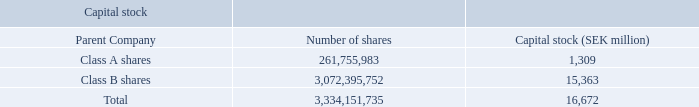Capital stock 2019
Capital stock at December 31, 2019, consisted of the following:
The capital stock of the Parent Company is divided into two classes: Class A shares (quota value SEK 5.00) and Class B shares (quota value SEK 5.00). Both classes have the same rights of participation in the net assets and earnings.Class A shares, however, are entitled to one vote per share while Class B shares are entitled to one tenth of one vote per share.
At December 31, 2019, the total number of treasury shares was 19,853,247 (37,057,039 in 2018 and 50,265,499 in 2017) Class B shares.
How are the capital stock of the parent company divided? Class a shares (quota value sek 5.00) and class b shares (quota value sek 5.00). What is the total number of treasury shares in 2019? 19,853,247. How many votes are class A shares entitled? One vote per share. What is the difference in the number of shares between class A and class B? 3,072,395,752-261,755,983
Answer: 2810639769. What is the difference between capital stock value in class A and B shares?
Answer scale should be: million. 15,363-1,309
Answer: 14054. What is the price of each class A share?  1,309*1million/261,755,983
Answer: 5. 